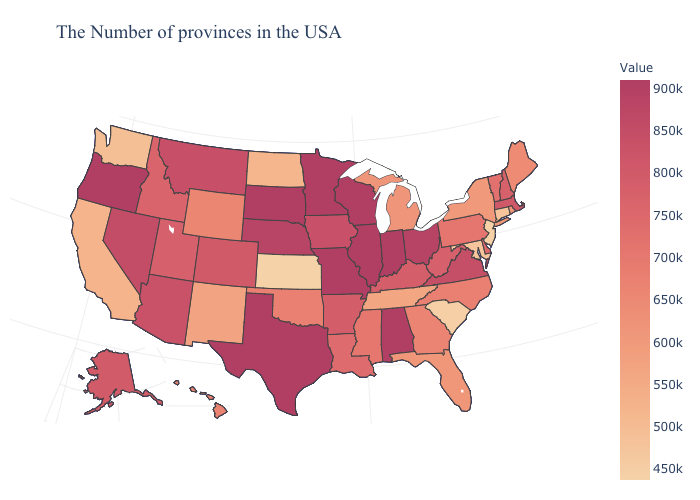Which states have the lowest value in the USA?
Give a very brief answer. Kansas. Does the map have missing data?
Give a very brief answer. No. Does Massachusetts have the lowest value in the USA?
Write a very short answer. No. Does Louisiana have the highest value in the USA?
Give a very brief answer. No. Which states hav the highest value in the Northeast?
Short answer required. Massachusetts. Among the states that border California , which have the lowest value?
Keep it brief. Arizona. Does the map have missing data?
Short answer required. No. 